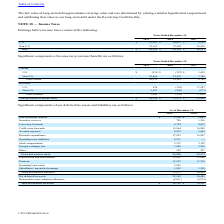From Cts Corporation's financial document, Which years does the table provide information for Earnings before income taxes? The document contains multiple relevant values: 2019, 2018, 2017. From the document: "2019 2018 2017 2019 2018 2017 2019 2018 2017..." Also, What was the total earnings in 2019? According to the financial document, 50,266 (in thousands). The relevant text states: "Total $ 50,266 $ 58,103 $ 40,253..." Also, What was the amount of earnings from Non-U.S. sources in 2017? According to the financial document, 30,938 (in thousands). The relevant text states: "Non-U.S. 35,163 27,288 30,938..." Additionally, Which years did earnings from Non-U.S. sources exceed $30,000 thousand? The document shows two values: 2019 and 2017. From the document: "2019 2018 2017 2019 2018 2017..." Also, can you calculate: What was the change in the earnings from U.S. between 2017 and 2018? Based on the calculation: 30,815-9,315, the result is 21500 (in thousands). This is based on the information: "U.S. $ 15,103 $ 30,815 $ 9,315 U.S. $ 15,103 $ 30,815 $ 9,315..." The key data points involved are: 30,815, 9,315. Also, can you calculate: What was the percentage change in the total earnings between 2018 and 2019? To answer this question, I need to perform calculations using the financial data. The calculation is: (50,266-58,103)/58,103, which equals -13.49 (percentage). This is based on the information: "Total $ 50,266 $ 58,103 $ 40,253 Total $ 50,266 $ 58,103 $ 40,253..." The key data points involved are: 50,266, 58,103. 